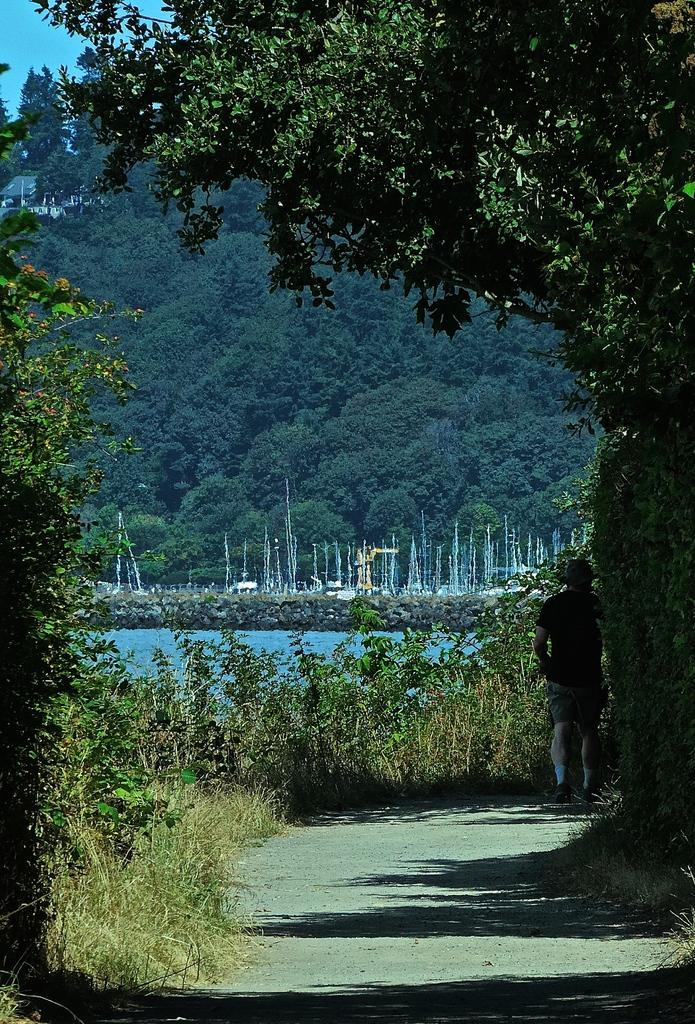What is the main subject of the image? There is a person standing in the image. What other elements can be seen in the image besides the person? There are plants, trees, boats, water, and the sky visible in the image. Can you describe the natural environment in the image? The image features plants, trees, and water, suggesting a natural setting. What type of watercraft can be seen in the image? There are boats visible in the image. What disease is the person in the image suffering from? There is no indication in the image that the person is suffering from any disease. What type of ground can be seen in the image? The image does not show the ground; it primarily features water and boats. 